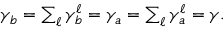<formula> <loc_0><loc_0><loc_500><loc_500>\begin{array} { r } { \gamma _ { b } = \sum _ { \ell } \gamma _ { b } ^ { \ell } = \gamma _ { a } = \sum _ { \ell } \gamma _ { a } ^ { \ell } = \gamma . } \end{array}</formula> 